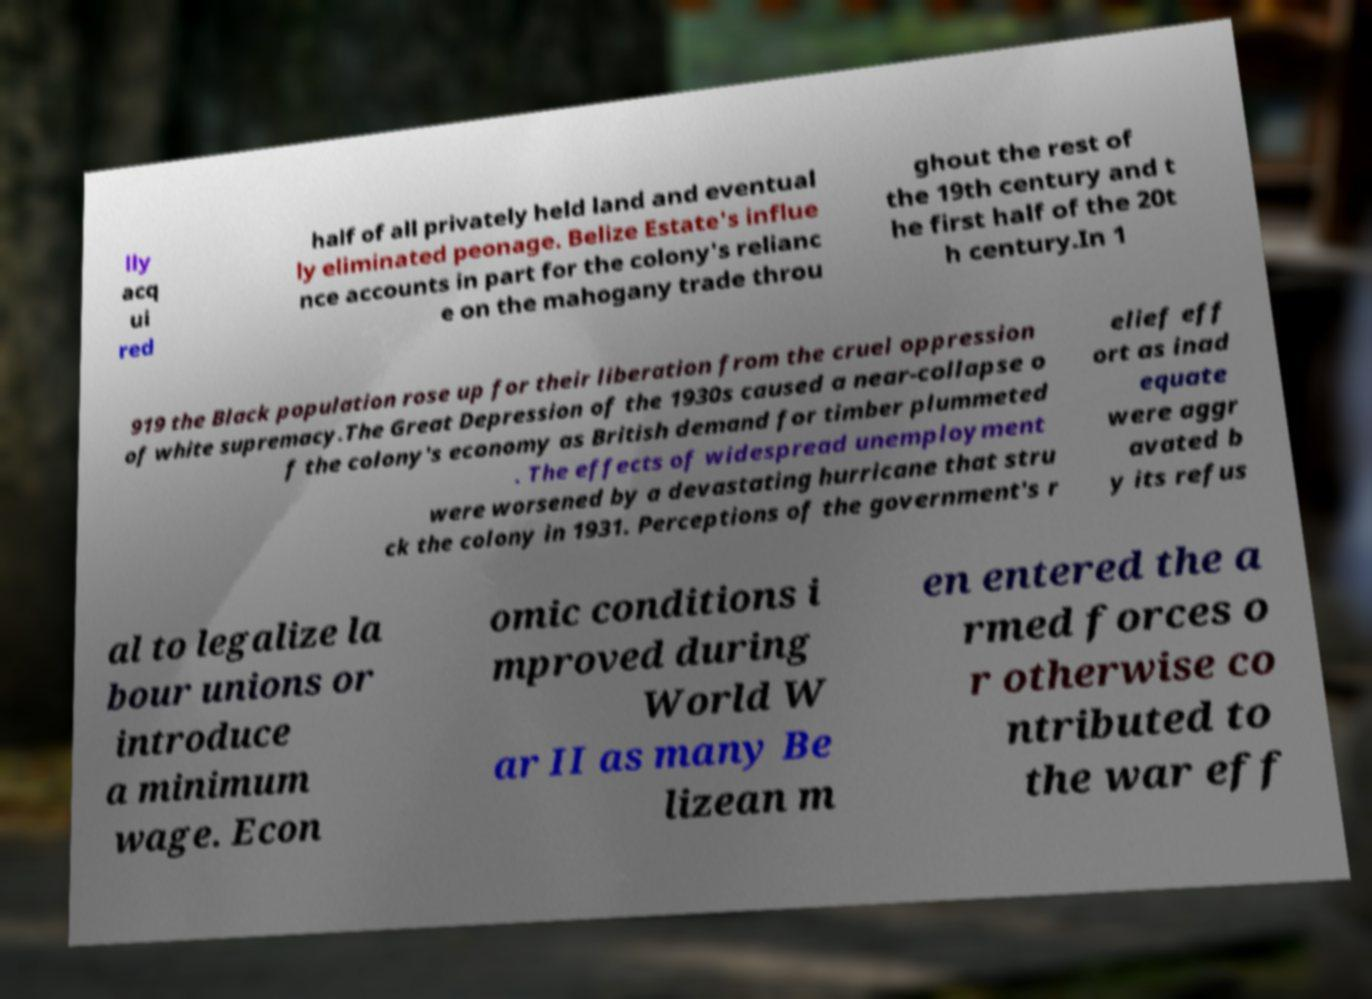Please identify and transcribe the text found in this image. lly acq ui red half of all privately held land and eventual ly eliminated peonage. Belize Estate's influe nce accounts in part for the colony's relianc e on the mahogany trade throu ghout the rest of the 19th century and t he first half of the 20t h century.In 1 919 the Black population rose up for their liberation from the cruel oppression of white supremacy.The Great Depression of the 1930s caused a near-collapse o f the colony's economy as British demand for timber plummeted . The effects of widespread unemployment were worsened by a devastating hurricane that stru ck the colony in 1931. Perceptions of the government's r elief eff ort as inad equate were aggr avated b y its refus al to legalize la bour unions or introduce a minimum wage. Econ omic conditions i mproved during World W ar II as many Be lizean m en entered the a rmed forces o r otherwise co ntributed to the war eff 